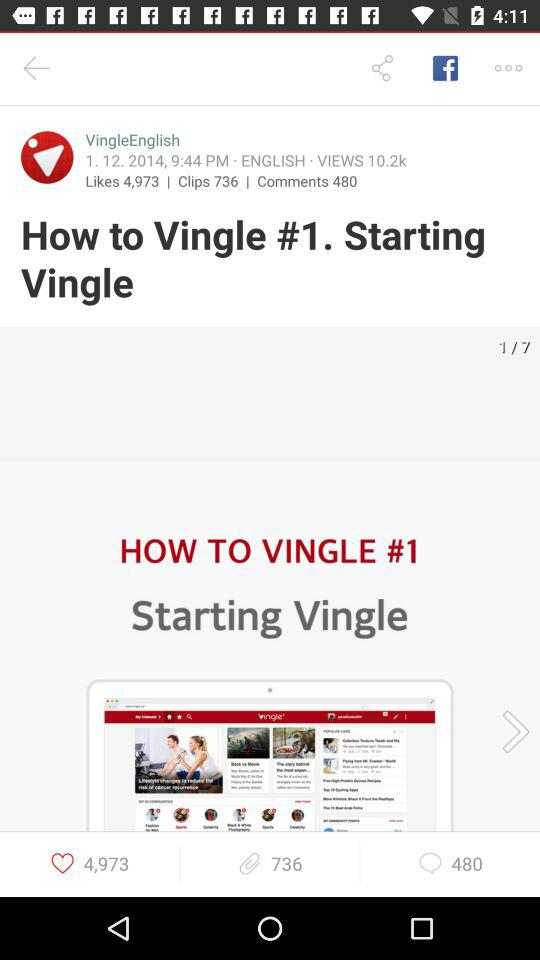How many more clips than comments does this video have?
Answer the question using a single word or phrase. 256 